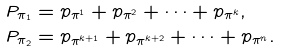<formula> <loc_0><loc_0><loc_500><loc_500>P _ { \pi _ { 1 } } & = p _ { \pi ^ { 1 } } + p _ { \pi ^ { 2 } } + \dots + p _ { \pi ^ { k } } , \\ P _ { \pi _ { 2 } } & = p _ { \pi ^ { k + 1 } } + p _ { \pi ^ { k + 2 } } + \dots + p _ { \pi ^ { n } } .</formula> 